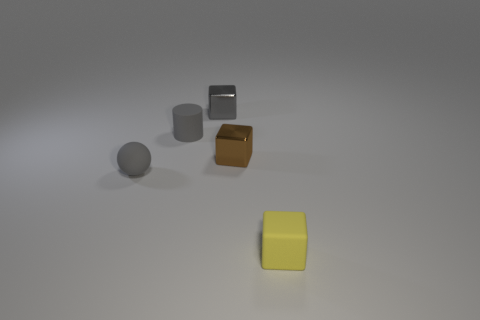Add 5 tiny brown objects. How many objects exist? 10 Subtract all blocks. How many objects are left? 2 Add 5 tiny gray balls. How many tiny gray balls exist? 6 Subtract 1 gray cylinders. How many objects are left? 4 Subtract all small gray spheres. Subtract all big blue matte cubes. How many objects are left? 4 Add 2 gray balls. How many gray balls are left? 3 